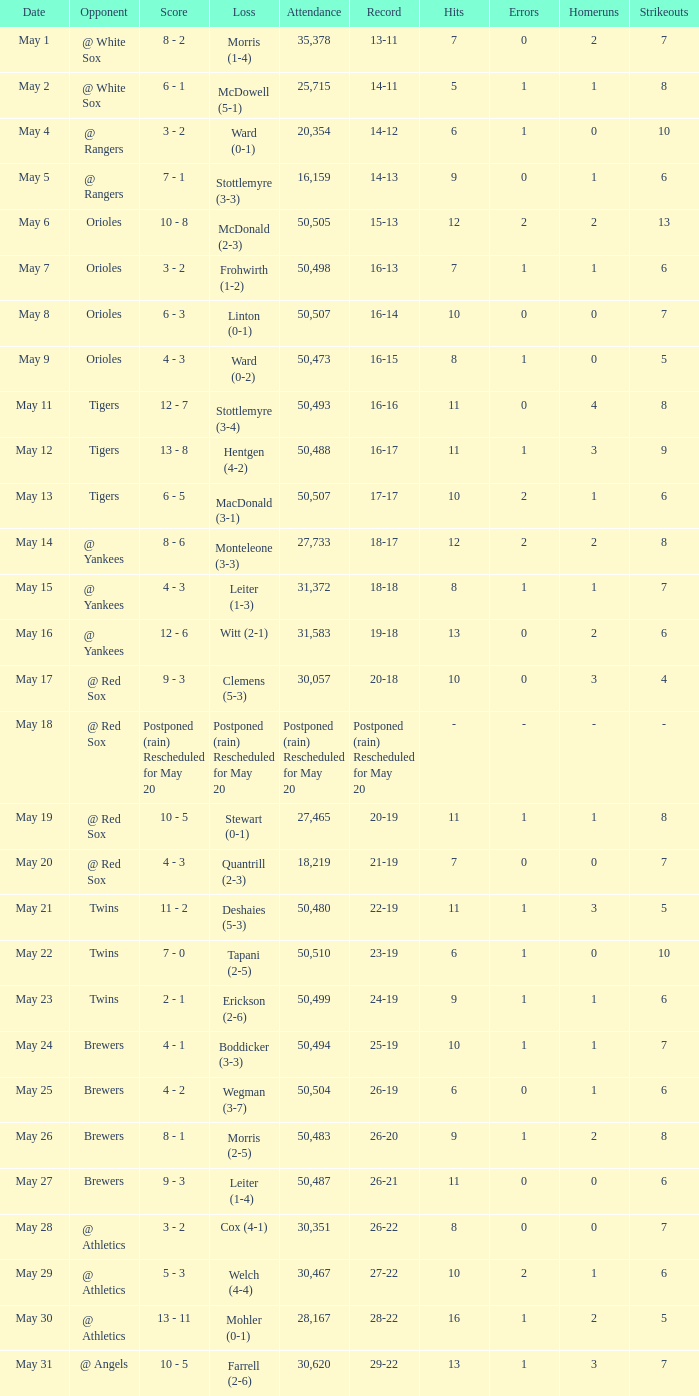Would you be able to parse every entry in this table? {'header': ['Date', 'Opponent', 'Score', 'Loss', 'Attendance', 'Record', 'Hits', 'Errors', 'Homeruns', 'Strikeouts'], 'rows': [['May 1', '@ White Sox', '8 - 2', 'Morris (1-4)', '35,378', '13-11', '7', '0', '2', '7'], ['May 2', '@ White Sox', '6 - 1', 'McDowell (5-1)', '25,715', '14-11', '5', '1', '1', '8'], ['May 4', '@ Rangers', '3 - 2', 'Ward (0-1)', '20,354', '14-12', '6', '1', '0', '10'], ['May 5', '@ Rangers', '7 - 1', 'Stottlemyre (3-3)', '16,159', '14-13', '9', '0', '1', '6'], ['May 6', 'Orioles', '10 - 8', 'McDonald (2-3)', '50,505', '15-13', '12', '2', '2', '13'], ['May 7', 'Orioles', '3 - 2', 'Frohwirth (1-2)', '50,498', '16-13', '7', '1', '1', '6'], ['May 8', 'Orioles', '6 - 3', 'Linton (0-1)', '50,507', '16-14', '10', '0', '0', '7'], ['May 9', 'Orioles', '4 - 3', 'Ward (0-2)', '50,473', '16-15', '8', '1', '0', '5'], ['May 11', 'Tigers', '12 - 7', 'Stottlemyre (3-4)', '50,493', '16-16', '11', '0', '4', '8'], ['May 12', 'Tigers', '13 - 8', 'Hentgen (4-2)', '50,488', '16-17', '11', '1', '3', '9'], ['May 13', 'Tigers', '6 - 5', 'MacDonald (3-1)', '50,507', '17-17', '10', '2', '1', '6'], ['May 14', '@ Yankees', '8 - 6', 'Monteleone (3-3)', '27,733', '18-17', '12', '2', '2', '8'], ['May 15', '@ Yankees', '4 - 3', 'Leiter (1-3)', '31,372', '18-18', '8', '1', '1', '7'], ['May 16', '@ Yankees', '12 - 6', 'Witt (2-1)', '31,583', '19-18', '13', '0', '2', '6'], ['May 17', '@ Red Sox', '9 - 3', 'Clemens (5-3)', '30,057', '20-18', '10', '0', '3', '4'], ['May 18', '@ Red Sox', 'Postponed (rain) Rescheduled for May 20', 'Postponed (rain) Rescheduled for May 20', 'Postponed (rain) Rescheduled for May 20', 'Postponed (rain) Rescheduled for May 20', '-', '-', '-', '-'], ['May 19', '@ Red Sox', '10 - 5', 'Stewart (0-1)', '27,465', '20-19', '11', '1', '1', '8'], ['May 20', '@ Red Sox', '4 - 3', 'Quantrill (2-3)', '18,219', '21-19', '7', '0', '0', '7'], ['May 21', 'Twins', '11 - 2', 'Deshaies (5-3)', '50,480', '22-19', '11', '1', '3', '5'], ['May 22', 'Twins', '7 - 0', 'Tapani (2-5)', '50,510', '23-19', '6', '1', '0', '10'], ['May 23', 'Twins', '2 - 1', 'Erickson (2-6)', '50,499', '24-19', '9', '1', '1', '6'], ['May 24', 'Brewers', '4 - 1', 'Boddicker (3-3)', '50,494', '25-19', '10', '1', '1', '7'], ['May 25', 'Brewers', '4 - 2', 'Wegman (3-7)', '50,504', '26-19', '6', '0', '1', '6'], ['May 26', 'Brewers', '8 - 1', 'Morris (2-5)', '50,483', '26-20', '9', '1', '2', '8'], ['May 27', 'Brewers', '9 - 3', 'Leiter (1-4)', '50,487', '26-21', '11', '0', '0', '6'], ['May 28', '@ Athletics', '3 - 2', 'Cox (4-1)', '30,351', '26-22', '8', '0', '0', '7'], ['May 29', '@ Athletics', '5 - 3', 'Welch (4-4)', '30,467', '27-22', '10', '2', '1', '6'], ['May 30', '@ Athletics', '13 - 11', 'Mohler (0-1)', '28,167', '28-22', '16', '1', '2', '5'], ['May 31', '@ Angels', '10 - 5', 'Farrell (2-6)', '30,620', '29-22', '13', '1', '3', '7']]} What team did they lose to when they had a 28-22 record? Mohler (0-1). 